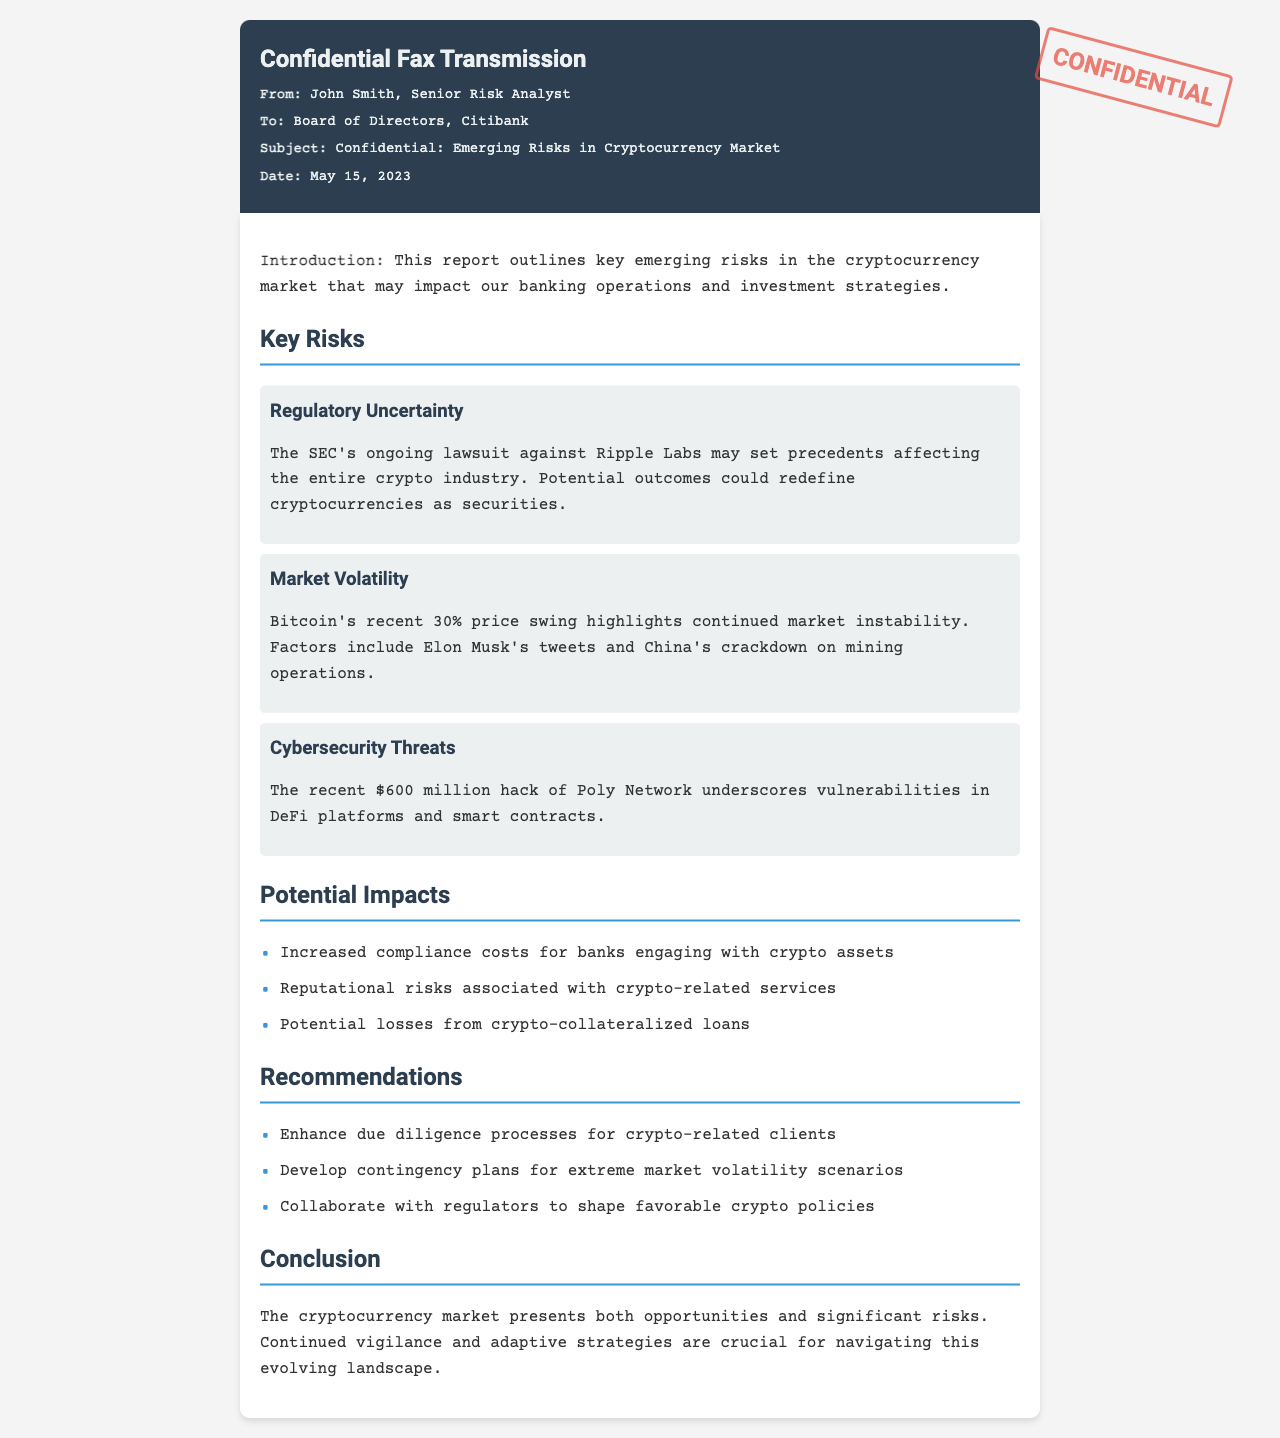what is the date of the fax? The date of the fax is mentioned clearly in the header of the document.
Answer: May 15, 2023 who is the sender of the fax? The sender's name is provided in the document's header section.
Answer: John Smith what is one key risk mentioned related to cybersecurity? The document outlines specific risks and highlights cybersecurity threats as a key risk.
Answer: $600 million hack of Poly Network which cryptocurrency had a recent 30% price swing? The document notes that Bitcoin experienced a significant price fluctuation.
Answer: Bitcoin what are the potential impacts listed regarding banks? The document discusses various impacts of cryptocurrency risks on banking operations.
Answer: Increased compliance costs for banks engaging with crypto assets what does the document suggest as a recommendation for extreme market situations? The recommendations provide guidance for risk management in case of significant market events.
Answer: Develop contingency plans for extreme market volatility scenarios how does the document label itself? The document contains a specific stamp indicating its nature for readers.
Answer: CONFIDENTIAL what ongoing legal issue is mentioned that may affect the crypto industry? The document refers to a specific lawsuit that has implications for the entire cryptocurrency market.
Answer: SEC's ongoing lawsuit against Ripple Labs 